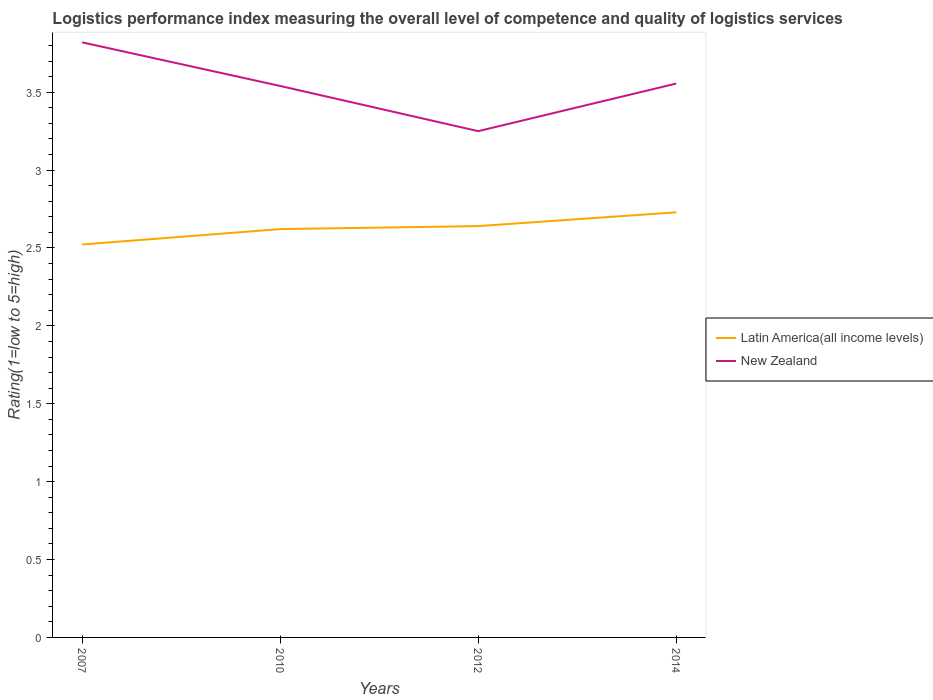How many different coloured lines are there?
Make the answer very short. 2. Does the line corresponding to New Zealand intersect with the line corresponding to Latin America(all income levels)?
Ensure brevity in your answer.  No. Is the number of lines equal to the number of legend labels?
Ensure brevity in your answer.  Yes. In which year was the Logistic performance index in Latin America(all income levels) maximum?
Provide a succinct answer. 2007. What is the total Logistic performance index in New Zealand in the graph?
Your answer should be very brief. 0.28. What is the difference between the highest and the second highest Logistic performance index in New Zealand?
Offer a terse response. 0.57. How many lines are there?
Your answer should be very brief. 2. Does the graph contain any zero values?
Offer a terse response. No. How are the legend labels stacked?
Your answer should be compact. Vertical. What is the title of the graph?
Your answer should be very brief. Logistics performance index measuring the overall level of competence and quality of logistics services. Does "Iceland" appear as one of the legend labels in the graph?
Make the answer very short. No. What is the label or title of the X-axis?
Provide a succinct answer. Years. What is the label or title of the Y-axis?
Your answer should be very brief. Rating(1=low to 5=high). What is the Rating(1=low to 5=high) of Latin America(all income levels) in 2007?
Your answer should be compact. 2.52. What is the Rating(1=low to 5=high) in New Zealand in 2007?
Your answer should be very brief. 3.82. What is the Rating(1=low to 5=high) in Latin America(all income levels) in 2010?
Provide a short and direct response. 2.62. What is the Rating(1=low to 5=high) in New Zealand in 2010?
Give a very brief answer. 3.54. What is the Rating(1=low to 5=high) in Latin America(all income levels) in 2012?
Offer a very short reply. 2.64. What is the Rating(1=low to 5=high) in Latin America(all income levels) in 2014?
Keep it short and to the point. 2.73. What is the Rating(1=low to 5=high) of New Zealand in 2014?
Your response must be concise. 3.56. Across all years, what is the maximum Rating(1=low to 5=high) in Latin America(all income levels)?
Give a very brief answer. 2.73. Across all years, what is the maximum Rating(1=low to 5=high) in New Zealand?
Keep it short and to the point. 3.82. Across all years, what is the minimum Rating(1=low to 5=high) of Latin America(all income levels)?
Keep it short and to the point. 2.52. What is the total Rating(1=low to 5=high) of Latin America(all income levels) in the graph?
Give a very brief answer. 10.51. What is the total Rating(1=low to 5=high) in New Zealand in the graph?
Keep it short and to the point. 14.17. What is the difference between the Rating(1=low to 5=high) of Latin America(all income levels) in 2007 and that in 2010?
Give a very brief answer. -0.1. What is the difference between the Rating(1=low to 5=high) of New Zealand in 2007 and that in 2010?
Offer a very short reply. 0.28. What is the difference between the Rating(1=low to 5=high) in Latin America(all income levels) in 2007 and that in 2012?
Give a very brief answer. -0.12. What is the difference between the Rating(1=low to 5=high) in New Zealand in 2007 and that in 2012?
Provide a succinct answer. 0.57. What is the difference between the Rating(1=low to 5=high) in Latin America(all income levels) in 2007 and that in 2014?
Your answer should be compact. -0.21. What is the difference between the Rating(1=low to 5=high) of New Zealand in 2007 and that in 2014?
Offer a very short reply. 0.26. What is the difference between the Rating(1=low to 5=high) of Latin America(all income levels) in 2010 and that in 2012?
Your response must be concise. -0.02. What is the difference between the Rating(1=low to 5=high) of New Zealand in 2010 and that in 2012?
Ensure brevity in your answer.  0.29. What is the difference between the Rating(1=low to 5=high) of Latin America(all income levels) in 2010 and that in 2014?
Provide a succinct answer. -0.11. What is the difference between the Rating(1=low to 5=high) in New Zealand in 2010 and that in 2014?
Ensure brevity in your answer.  -0.02. What is the difference between the Rating(1=low to 5=high) of Latin America(all income levels) in 2012 and that in 2014?
Your answer should be very brief. -0.09. What is the difference between the Rating(1=low to 5=high) of New Zealand in 2012 and that in 2014?
Ensure brevity in your answer.  -0.31. What is the difference between the Rating(1=low to 5=high) in Latin America(all income levels) in 2007 and the Rating(1=low to 5=high) in New Zealand in 2010?
Provide a succinct answer. -1.02. What is the difference between the Rating(1=low to 5=high) of Latin America(all income levels) in 2007 and the Rating(1=low to 5=high) of New Zealand in 2012?
Make the answer very short. -0.73. What is the difference between the Rating(1=low to 5=high) in Latin America(all income levels) in 2007 and the Rating(1=low to 5=high) in New Zealand in 2014?
Ensure brevity in your answer.  -1.03. What is the difference between the Rating(1=low to 5=high) of Latin America(all income levels) in 2010 and the Rating(1=low to 5=high) of New Zealand in 2012?
Your response must be concise. -0.63. What is the difference between the Rating(1=low to 5=high) of Latin America(all income levels) in 2010 and the Rating(1=low to 5=high) of New Zealand in 2014?
Your response must be concise. -0.93. What is the difference between the Rating(1=low to 5=high) in Latin America(all income levels) in 2012 and the Rating(1=low to 5=high) in New Zealand in 2014?
Provide a short and direct response. -0.92. What is the average Rating(1=low to 5=high) of Latin America(all income levels) per year?
Ensure brevity in your answer.  2.63. What is the average Rating(1=low to 5=high) of New Zealand per year?
Ensure brevity in your answer.  3.54. In the year 2007, what is the difference between the Rating(1=low to 5=high) in Latin America(all income levels) and Rating(1=low to 5=high) in New Zealand?
Offer a very short reply. -1.3. In the year 2010, what is the difference between the Rating(1=low to 5=high) in Latin America(all income levels) and Rating(1=low to 5=high) in New Zealand?
Ensure brevity in your answer.  -0.92. In the year 2012, what is the difference between the Rating(1=low to 5=high) in Latin America(all income levels) and Rating(1=low to 5=high) in New Zealand?
Keep it short and to the point. -0.61. In the year 2014, what is the difference between the Rating(1=low to 5=high) in Latin America(all income levels) and Rating(1=low to 5=high) in New Zealand?
Provide a succinct answer. -0.83. What is the ratio of the Rating(1=low to 5=high) of Latin America(all income levels) in 2007 to that in 2010?
Offer a terse response. 0.96. What is the ratio of the Rating(1=low to 5=high) in New Zealand in 2007 to that in 2010?
Your answer should be very brief. 1.08. What is the ratio of the Rating(1=low to 5=high) in Latin America(all income levels) in 2007 to that in 2012?
Provide a short and direct response. 0.96. What is the ratio of the Rating(1=low to 5=high) of New Zealand in 2007 to that in 2012?
Give a very brief answer. 1.18. What is the ratio of the Rating(1=low to 5=high) in Latin America(all income levels) in 2007 to that in 2014?
Make the answer very short. 0.92. What is the ratio of the Rating(1=low to 5=high) in New Zealand in 2007 to that in 2014?
Keep it short and to the point. 1.07. What is the ratio of the Rating(1=low to 5=high) of New Zealand in 2010 to that in 2012?
Keep it short and to the point. 1.09. What is the ratio of the Rating(1=low to 5=high) in Latin America(all income levels) in 2010 to that in 2014?
Provide a short and direct response. 0.96. What is the ratio of the Rating(1=low to 5=high) in Latin America(all income levels) in 2012 to that in 2014?
Give a very brief answer. 0.97. What is the ratio of the Rating(1=low to 5=high) of New Zealand in 2012 to that in 2014?
Make the answer very short. 0.91. What is the difference between the highest and the second highest Rating(1=low to 5=high) in Latin America(all income levels)?
Provide a succinct answer. 0.09. What is the difference between the highest and the second highest Rating(1=low to 5=high) of New Zealand?
Give a very brief answer. 0.26. What is the difference between the highest and the lowest Rating(1=low to 5=high) of Latin America(all income levels)?
Your answer should be very brief. 0.21. What is the difference between the highest and the lowest Rating(1=low to 5=high) of New Zealand?
Keep it short and to the point. 0.57. 